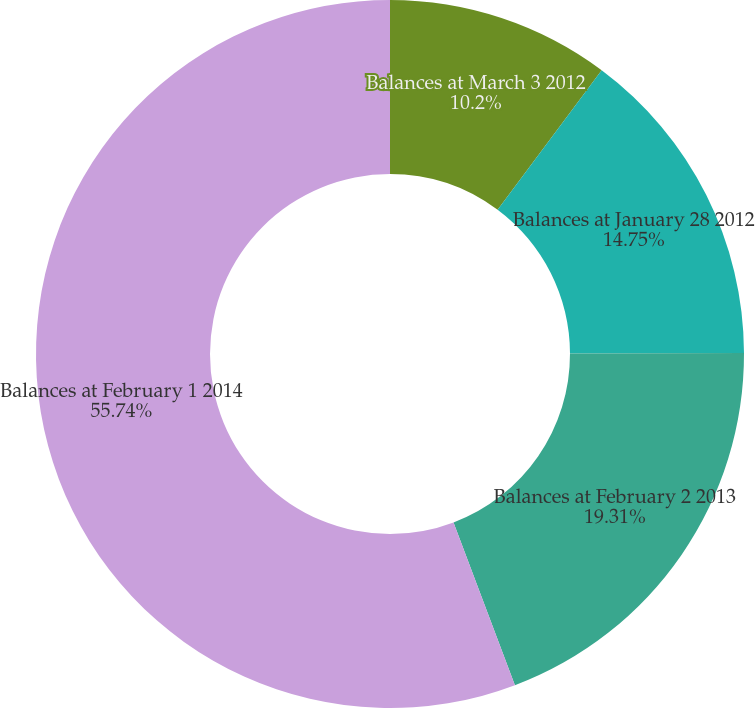Convert chart. <chart><loc_0><loc_0><loc_500><loc_500><pie_chart><fcel>Balances at March 3 2012<fcel>Balances at January 28 2012<fcel>Balances at February 2 2013<fcel>Balances at February 1 2014<nl><fcel>10.2%<fcel>14.75%<fcel>19.31%<fcel>55.74%<nl></chart> 